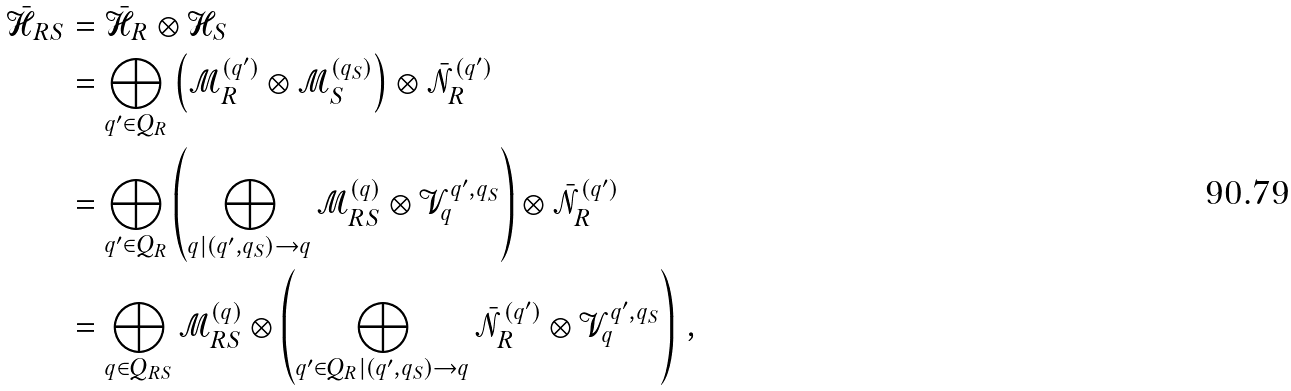Convert formula to latex. <formula><loc_0><loc_0><loc_500><loc_500>\bar { \mathcal { H } } _ { R S } & = \bar { \mathcal { H } } _ { R } \otimes \mathcal { H } _ { S } \\ & = \bigoplus _ { q ^ { \prime } \in Q _ { R } } \left ( \mathcal { M } ^ { ( q ^ { \prime } ) } _ { R } \otimes \mathcal { M } ^ { ( q _ { S } ) } _ { S } \right ) \otimes \bar { \mathcal { N } } ^ { ( q ^ { \prime } ) } _ { R } \\ & = \bigoplus _ { q ^ { \prime } \in Q _ { R } } \left ( \bigoplus _ { q | ( q ^ { \prime } , q _ { S } ) \to q } \mathcal { M } ^ { ( q ) } _ { R S } \otimes \mathcal { V } ^ { q ^ { \prime } , q _ { S } } _ { q } \right ) \otimes \bar { \mathcal { N } } ^ { ( q ^ { \prime } ) } _ { R } \\ & = \bigoplus _ { q \in Q _ { R S } } \mathcal { M } ^ { ( q ) } _ { R S } \otimes \left ( \bigoplus _ { q ^ { \prime } \in Q _ { R } | ( q ^ { \prime } , q _ { S } ) \to q } \bar { \mathcal { N } } ^ { ( q ^ { \prime } ) } _ { R } \otimes \mathcal { V } ^ { q ^ { \prime } , q _ { S } } _ { q } \right ) \, ,</formula> 